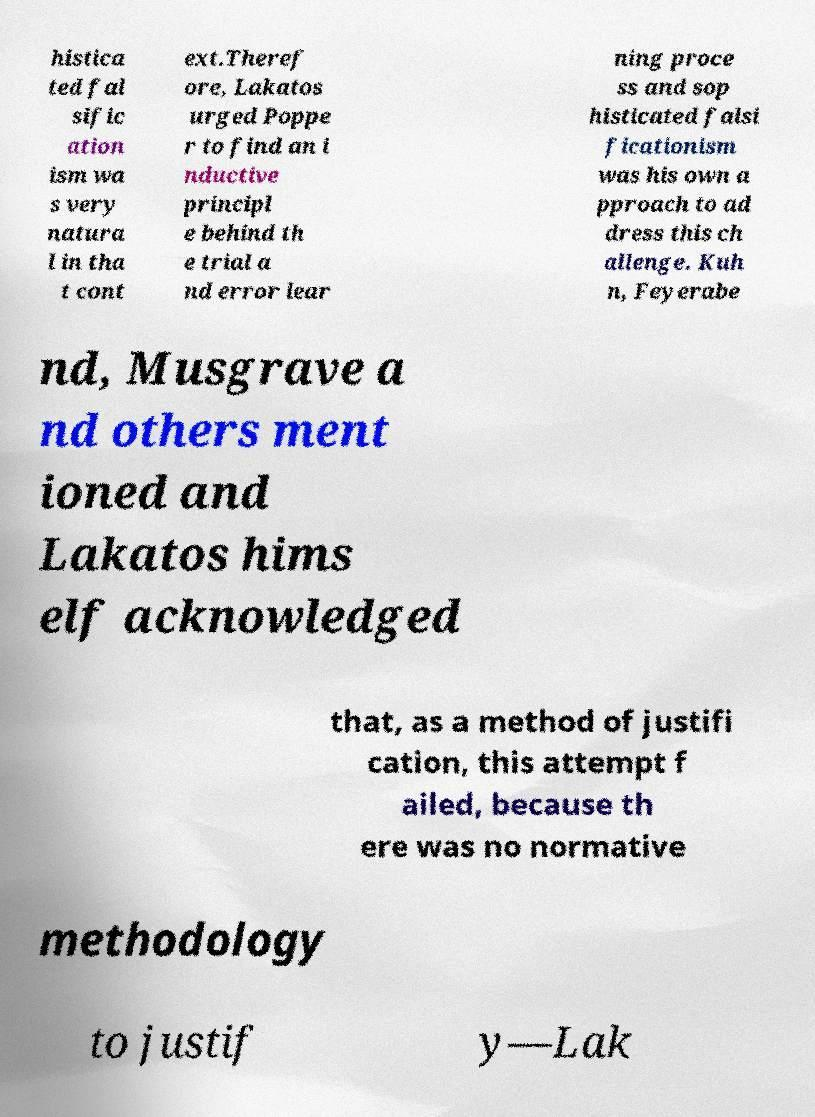There's text embedded in this image that I need extracted. Can you transcribe it verbatim? histica ted fal sific ation ism wa s very natura l in tha t cont ext.Theref ore, Lakatos urged Poppe r to find an i nductive principl e behind th e trial a nd error lear ning proce ss and sop histicated falsi ficationism was his own a pproach to ad dress this ch allenge. Kuh n, Feyerabe nd, Musgrave a nd others ment ioned and Lakatos hims elf acknowledged that, as a method of justifi cation, this attempt f ailed, because th ere was no normative methodology to justif y—Lak 